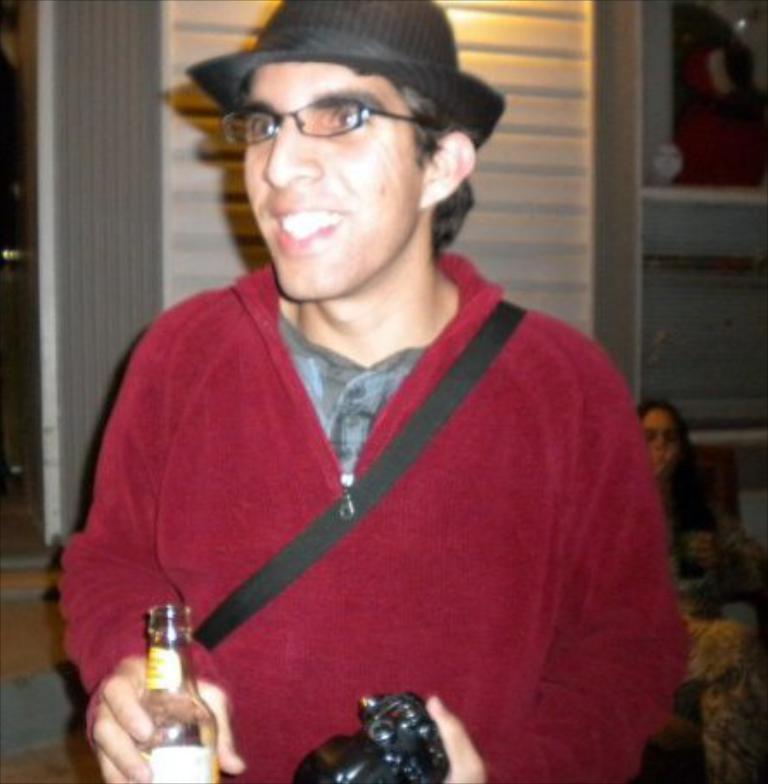Could you give a brief overview of what you see in this image? In the image we can see there is a man who is standing and holding wine bottle and camera in his hand. At the back there is a woman sitting on chair. 